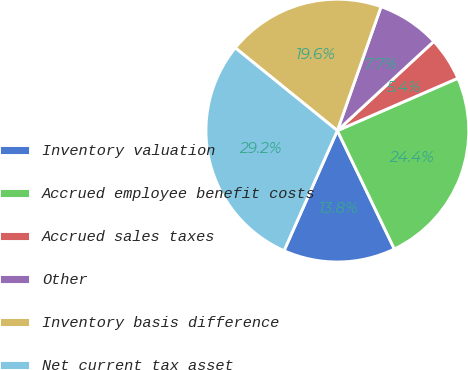<chart> <loc_0><loc_0><loc_500><loc_500><pie_chart><fcel>Inventory valuation<fcel>Accrued employee benefit costs<fcel>Accrued sales taxes<fcel>Other<fcel>Inventory basis difference<fcel>Net current tax asset<nl><fcel>13.79%<fcel>24.38%<fcel>5.35%<fcel>7.73%<fcel>19.55%<fcel>29.19%<nl></chart> 